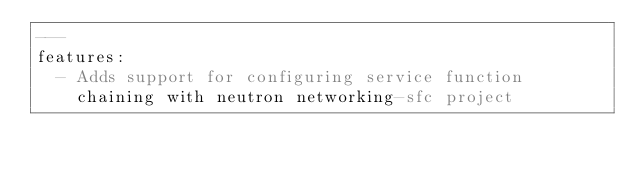<code> <loc_0><loc_0><loc_500><loc_500><_YAML_>---
features:
  - Adds support for configuring service function
    chaining with neutron networking-sfc project
</code> 